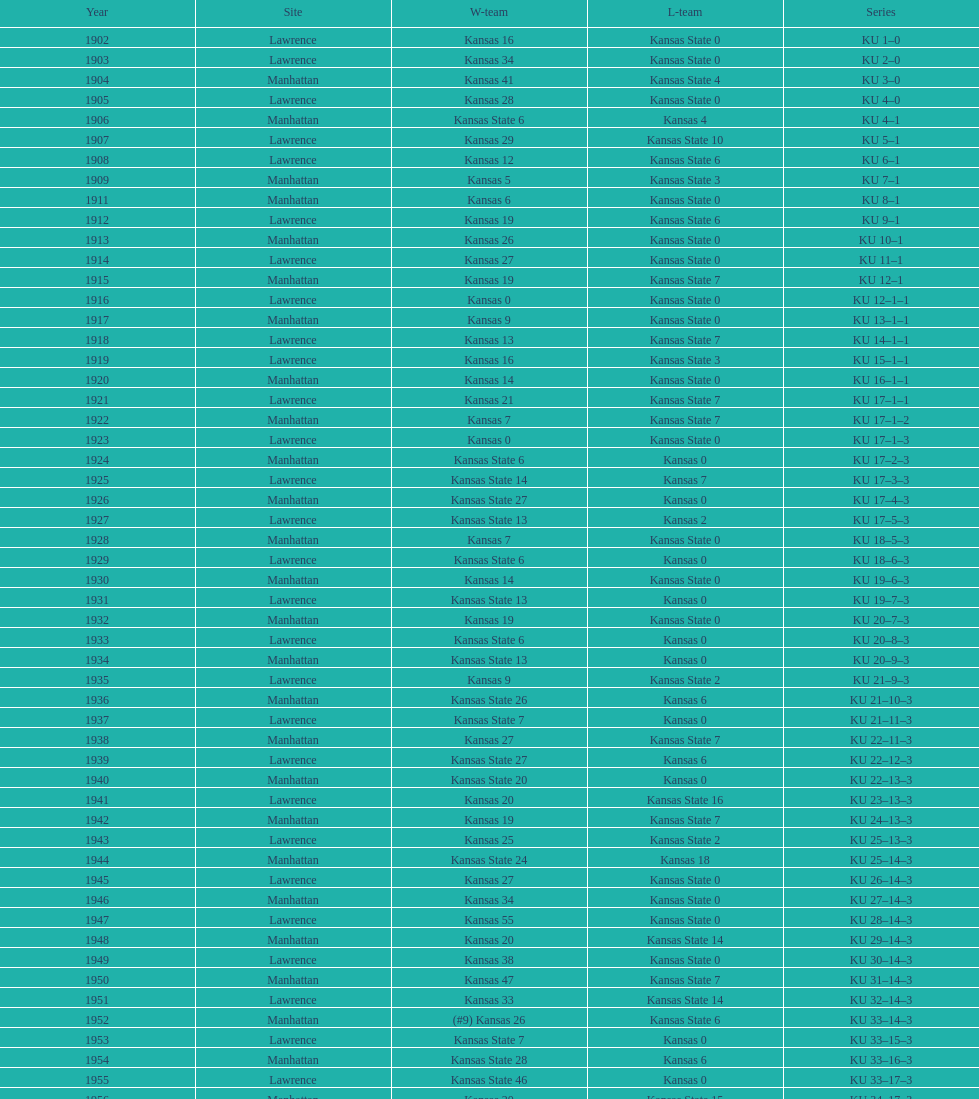How many times did kansas state not score at all against kansas from 1902-1968? 23. 